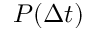Convert formula to latex. <formula><loc_0><loc_0><loc_500><loc_500>P ( \Delta t )</formula> 